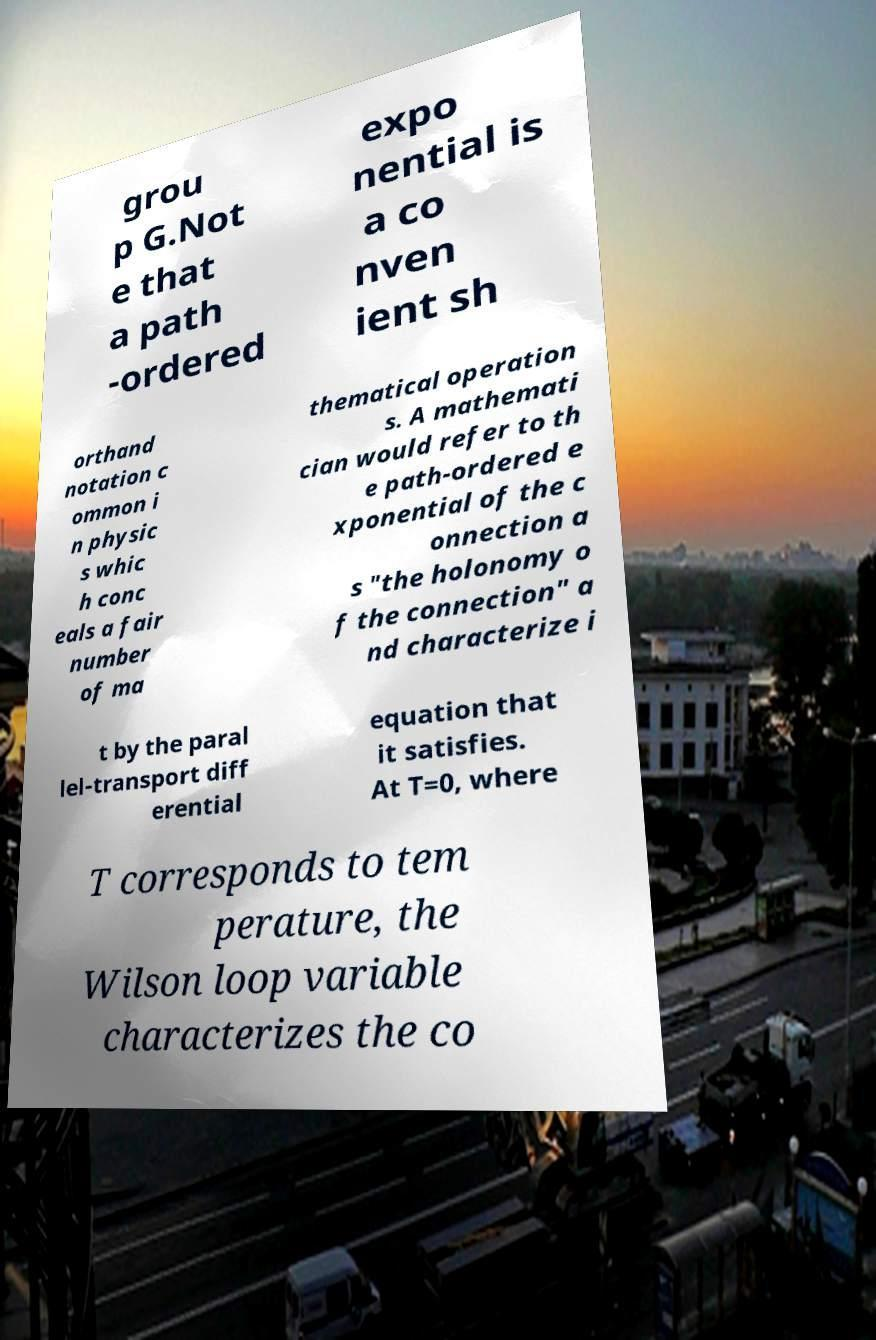For documentation purposes, I need the text within this image transcribed. Could you provide that? grou p G.Not e that a path -ordered expo nential is a co nven ient sh orthand notation c ommon i n physic s whic h conc eals a fair number of ma thematical operation s. A mathemati cian would refer to th e path-ordered e xponential of the c onnection a s "the holonomy o f the connection" a nd characterize i t by the paral lel-transport diff erential equation that it satisfies. At T=0, where T corresponds to tem perature, the Wilson loop variable characterizes the co 